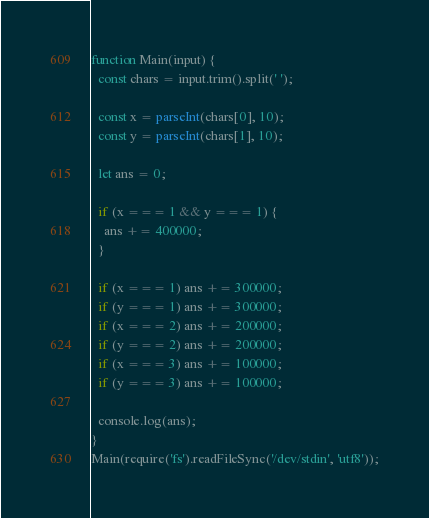<code> <loc_0><loc_0><loc_500><loc_500><_JavaScript_>function Main(input) {
  const chars = input.trim().split(' ');

  const x = parseInt(chars[0], 10);
  const y = parseInt(chars[1], 10);

  let ans = 0;

  if (x === 1 && y === 1) {
    ans += 400000;
  }

  if (x === 1) ans += 300000;
  if (y === 1) ans += 300000;
  if (x === 2) ans += 200000;
  if (y === 2) ans += 200000;
  if (x === 3) ans += 100000;
  if (y === 3) ans += 100000;

  console.log(ans);
}
Main(require('fs').readFileSync('/dev/stdin', 'utf8'));</code> 